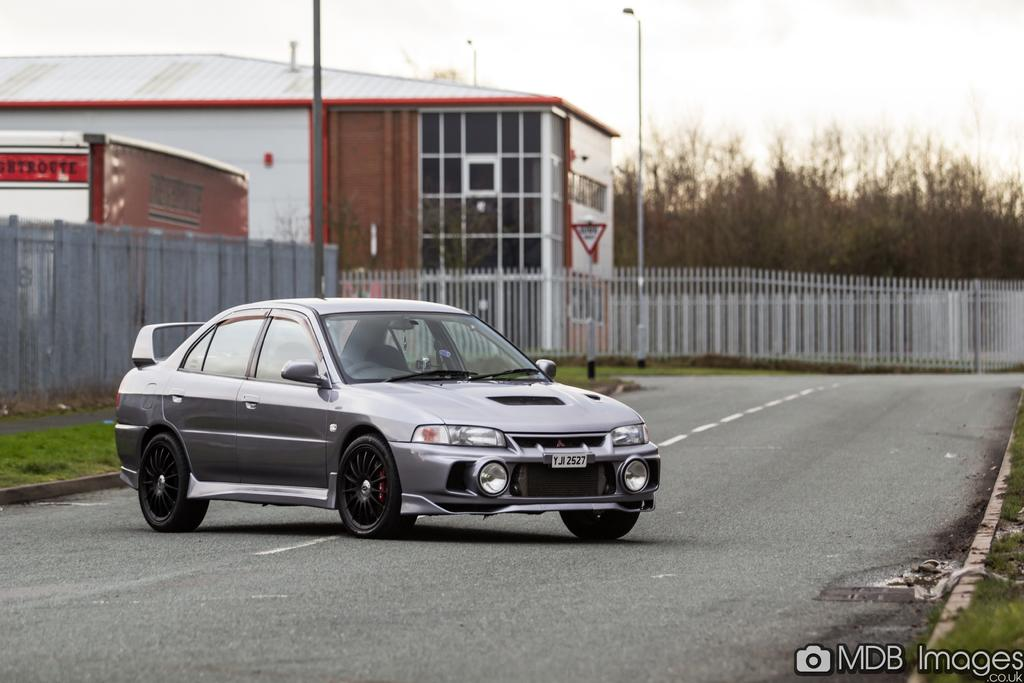What is the main subject of the image? The main subject of the image is a car on the road. What can be seen in the background of the image? In the background of the image, there is a fence, a house, poles, and trees. Is there any text or logo visible in the image? Yes, there is a watermark at the right bottom of the image. What type of baseball can be seen being played in the image? There is no baseball or any sports activity depicted in the image; it features a car on the road and background elements. How does the image sort the different elements in the background? The image does not sort the different elements in the background; it simply presents them as they are. 